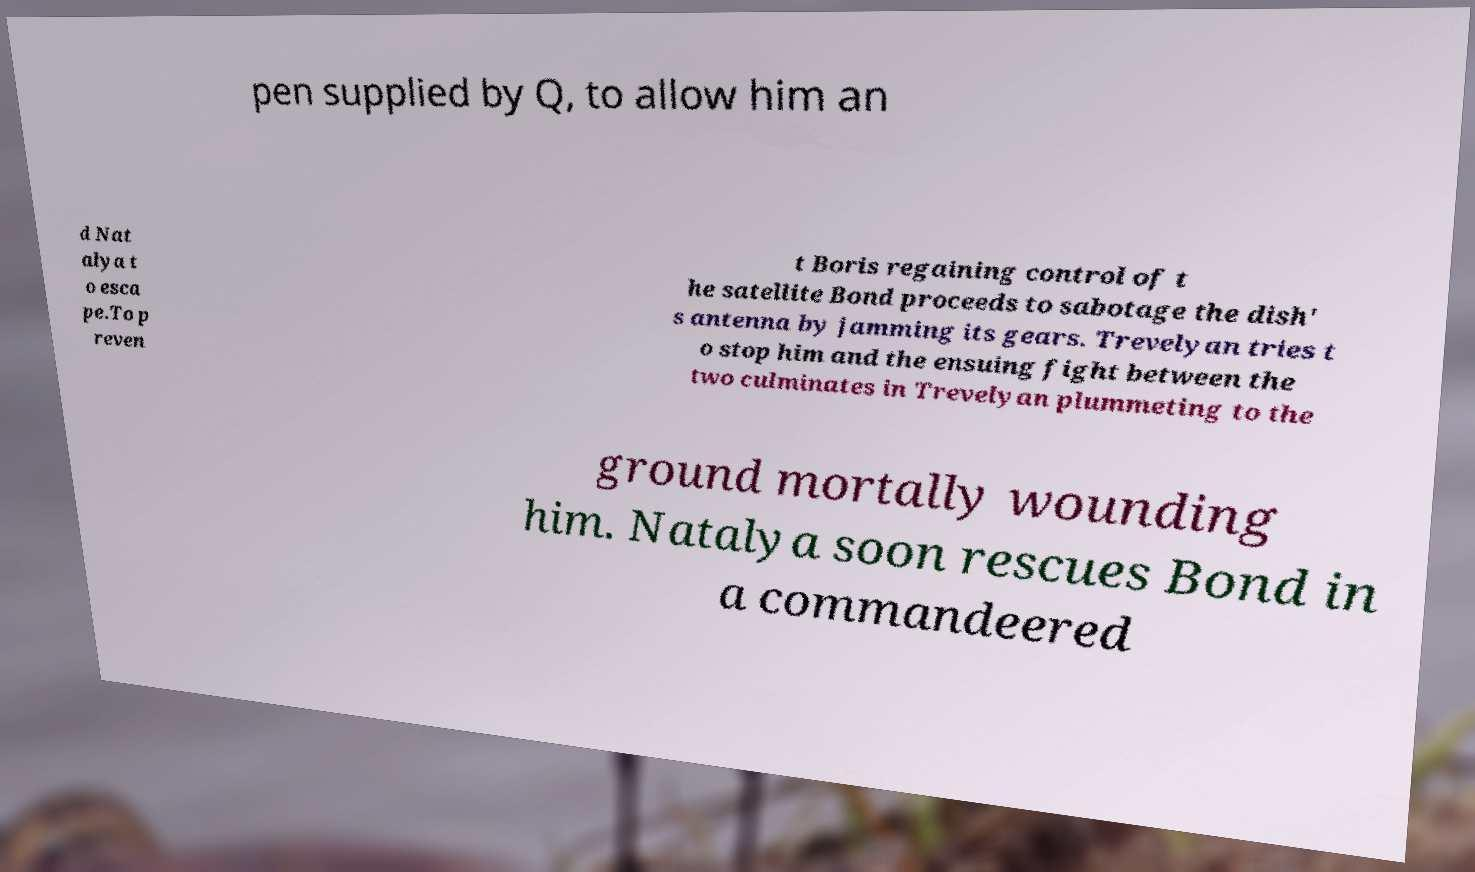Could you extract and type out the text from this image? pen supplied by Q, to allow him an d Nat alya t o esca pe.To p reven t Boris regaining control of t he satellite Bond proceeds to sabotage the dish' s antenna by jamming its gears. Trevelyan tries t o stop him and the ensuing fight between the two culminates in Trevelyan plummeting to the ground mortally wounding him. Natalya soon rescues Bond in a commandeered 